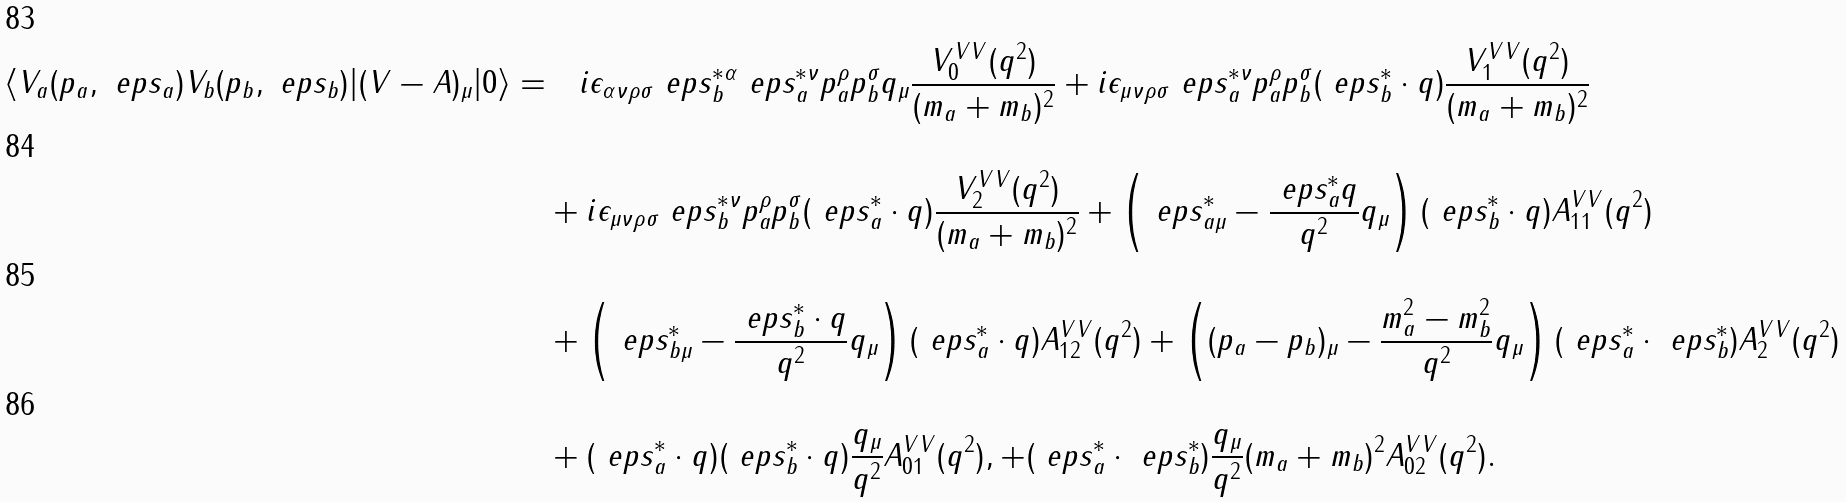Convert formula to latex. <formula><loc_0><loc_0><loc_500><loc_500>\langle V _ { a } ( p _ { a } , \ e p s _ { a } ) V _ { b } ( p _ { b } , \ e p s _ { b } ) | ( V - A ) _ { \mu } | 0 \rangle = & \quad i \epsilon _ { \alpha \nu \rho \sigma } \ e p s _ { b } ^ { * \alpha } \ e p s _ { a } ^ { * \nu } p _ { a } ^ { \rho } p _ { b } ^ { \sigma } q _ { \mu } \frac { V ^ { V V } _ { 0 } ( q ^ { 2 } ) } { ( m _ { a } + m _ { b } ) ^ { 2 } } + i \epsilon _ { \mu \nu \rho \sigma } \ e p s _ { a } ^ { * \nu } p _ { a } ^ { \rho } p _ { b } ^ { \sigma } ( \ e p s _ { b } ^ { * } \cdot q ) \frac { V ^ { V V } _ { 1 } ( q ^ { 2 } ) } { ( m _ { a } + m _ { b } ) ^ { 2 } } \\ & + i \epsilon _ { \mu \nu \rho \sigma } \ e p s _ { b } ^ { * \nu } p _ { a } ^ { \rho } p _ { b } ^ { \sigma } ( \ e p s _ { a } ^ { * } \cdot q ) \frac { V ^ { V V } _ { 2 } ( q ^ { 2 } ) } { ( m _ { a } + m _ { b } ) ^ { 2 } } + \left ( \ e p s ^ { * } _ { a \mu } - \frac { \ e p s _ { a } ^ { * } q } { q ^ { 2 } } q _ { \mu } \right ) ( \ e p s _ { b } ^ { * } \cdot q ) A _ { 1 1 } ^ { V V } ( q ^ { 2 } ) \\ & + \left ( \ e p s ^ { * } _ { b \mu } - \frac { \ e p s _ { b } ^ { * } \cdot q } { q ^ { 2 } } q _ { \mu } \right ) ( \ e p s _ { a } ^ { * } \cdot q ) A _ { 1 2 } ^ { V V } ( q ^ { 2 } ) + \left ( ( p _ { a } - p _ { b } ) _ { \mu } - \frac { m _ { a } ^ { 2 } - m _ { b } ^ { 2 } } { q ^ { 2 } } q _ { \mu } \right ) ( \ e p s _ { a } ^ { * } \cdot \ e p s _ { b } ^ { * } ) A _ { 2 } ^ { V V } ( q ^ { 2 } ) \\ & + ( \ e p s _ { a } ^ { * } \cdot q ) ( \ e p s _ { b } ^ { * } \cdot q ) \frac { q _ { \mu } } { q ^ { 2 } } A _ { 0 1 } ^ { V V } ( q ^ { 2 } ) , + ( \ e p s _ { a } ^ { * } \cdot \ e p s _ { b } ^ { * } ) \frac { q _ { \mu } } { q ^ { 2 } } ( m _ { a } + m _ { b } ) ^ { 2 } A _ { 0 2 } ^ { V V } ( q ^ { 2 } ) .</formula> 